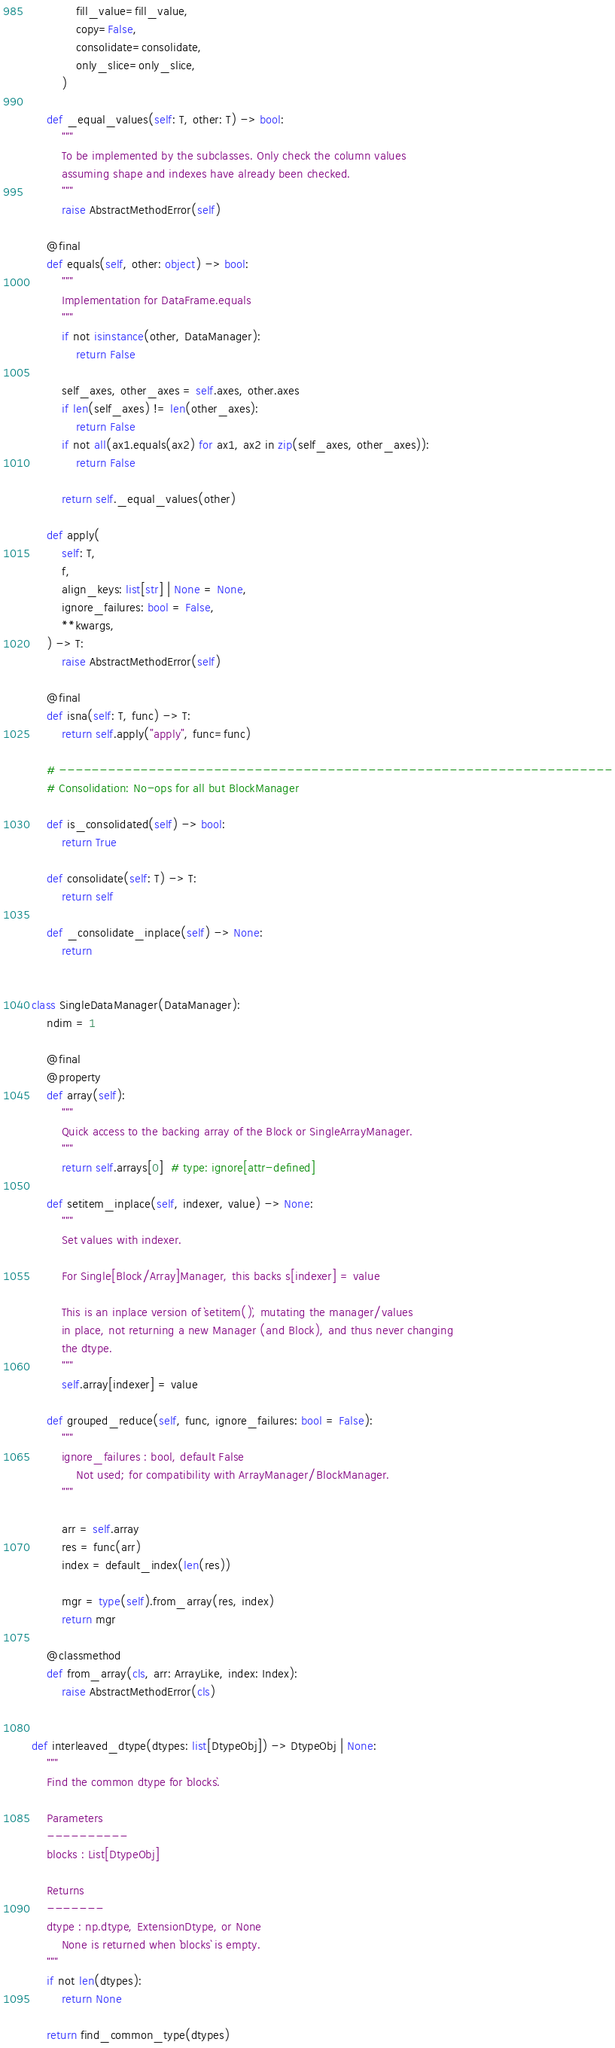Convert code to text. <code><loc_0><loc_0><loc_500><loc_500><_Python_>            fill_value=fill_value,
            copy=False,
            consolidate=consolidate,
            only_slice=only_slice,
        )

    def _equal_values(self: T, other: T) -> bool:
        """
        To be implemented by the subclasses. Only check the column values
        assuming shape and indexes have already been checked.
        """
        raise AbstractMethodError(self)

    @final
    def equals(self, other: object) -> bool:
        """
        Implementation for DataFrame.equals
        """
        if not isinstance(other, DataManager):
            return False

        self_axes, other_axes = self.axes, other.axes
        if len(self_axes) != len(other_axes):
            return False
        if not all(ax1.equals(ax2) for ax1, ax2 in zip(self_axes, other_axes)):
            return False

        return self._equal_values(other)

    def apply(
        self: T,
        f,
        align_keys: list[str] | None = None,
        ignore_failures: bool = False,
        **kwargs,
    ) -> T:
        raise AbstractMethodError(self)

    @final
    def isna(self: T, func) -> T:
        return self.apply("apply", func=func)

    # --------------------------------------------------------------------
    # Consolidation: No-ops for all but BlockManager

    def is_consolidated(self) -> bool:
        return True

    def consolidate(self: T) -> T:
        return self

    def _consolidate_inplace(self) -> None:
        return


class SingleDataManager(DataManager):
    ndim = 1

    @final
    @property
    def array(self):
        """
        Quick access to the backing array of the Block or SingleArrayManager.
        """
        return self.arrays[0]  # type: ignore[attr-defined]

    def setitem_inplace(self, indexer, value) -> None:
        """
        Set values with indexer.

        For Single[Block/Array]Manager, this backs s[indexer] = value

        This is an inplace version of `setitem()`, mutating the manager/values
        in place, not returning a new Manager (and Block), and thus never changing
        the dtype.
        """
        self.array[indexer] = value

    def grouped_reduce(self, func, ignore_failures: bool = False):
        """
        ignore_failures : bool, default False
            Not used; for compatibility with ArrayManager/BlockManager.
        """

        arr = self.array
        res = func(arr)
        index = default_index(len(res))

        mgr = type(self).from_array(res, index)
        return mgr

    @classmethod
    def from_array(cls, arr: ArrayLike, index: Index):
        raise AbstractMethodError(cls)


def interleaved_dtype(dtypes: list[DtypeObj]) -> DtypeObj | None:
    """
    Find the common dtype for `blocks`.

    Parameters
    ----------
    blocks : List[DtypeObj]

    Returns
    -------
    dtype : np.dtype, ExtensionDtype, or None
        None is returned when `blocks` is empty.
    """
    if not len(dtypes):
        return None

    return find_common_type(dtypes)
</code> 